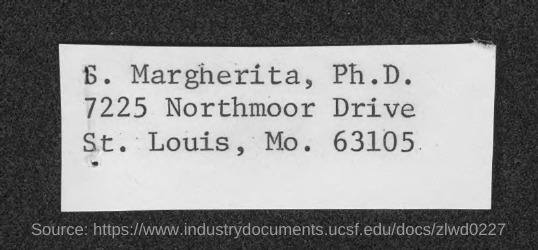Identify some key points in this picture. The zip code mentioned is 63105. The name is given to S. Margherita. 